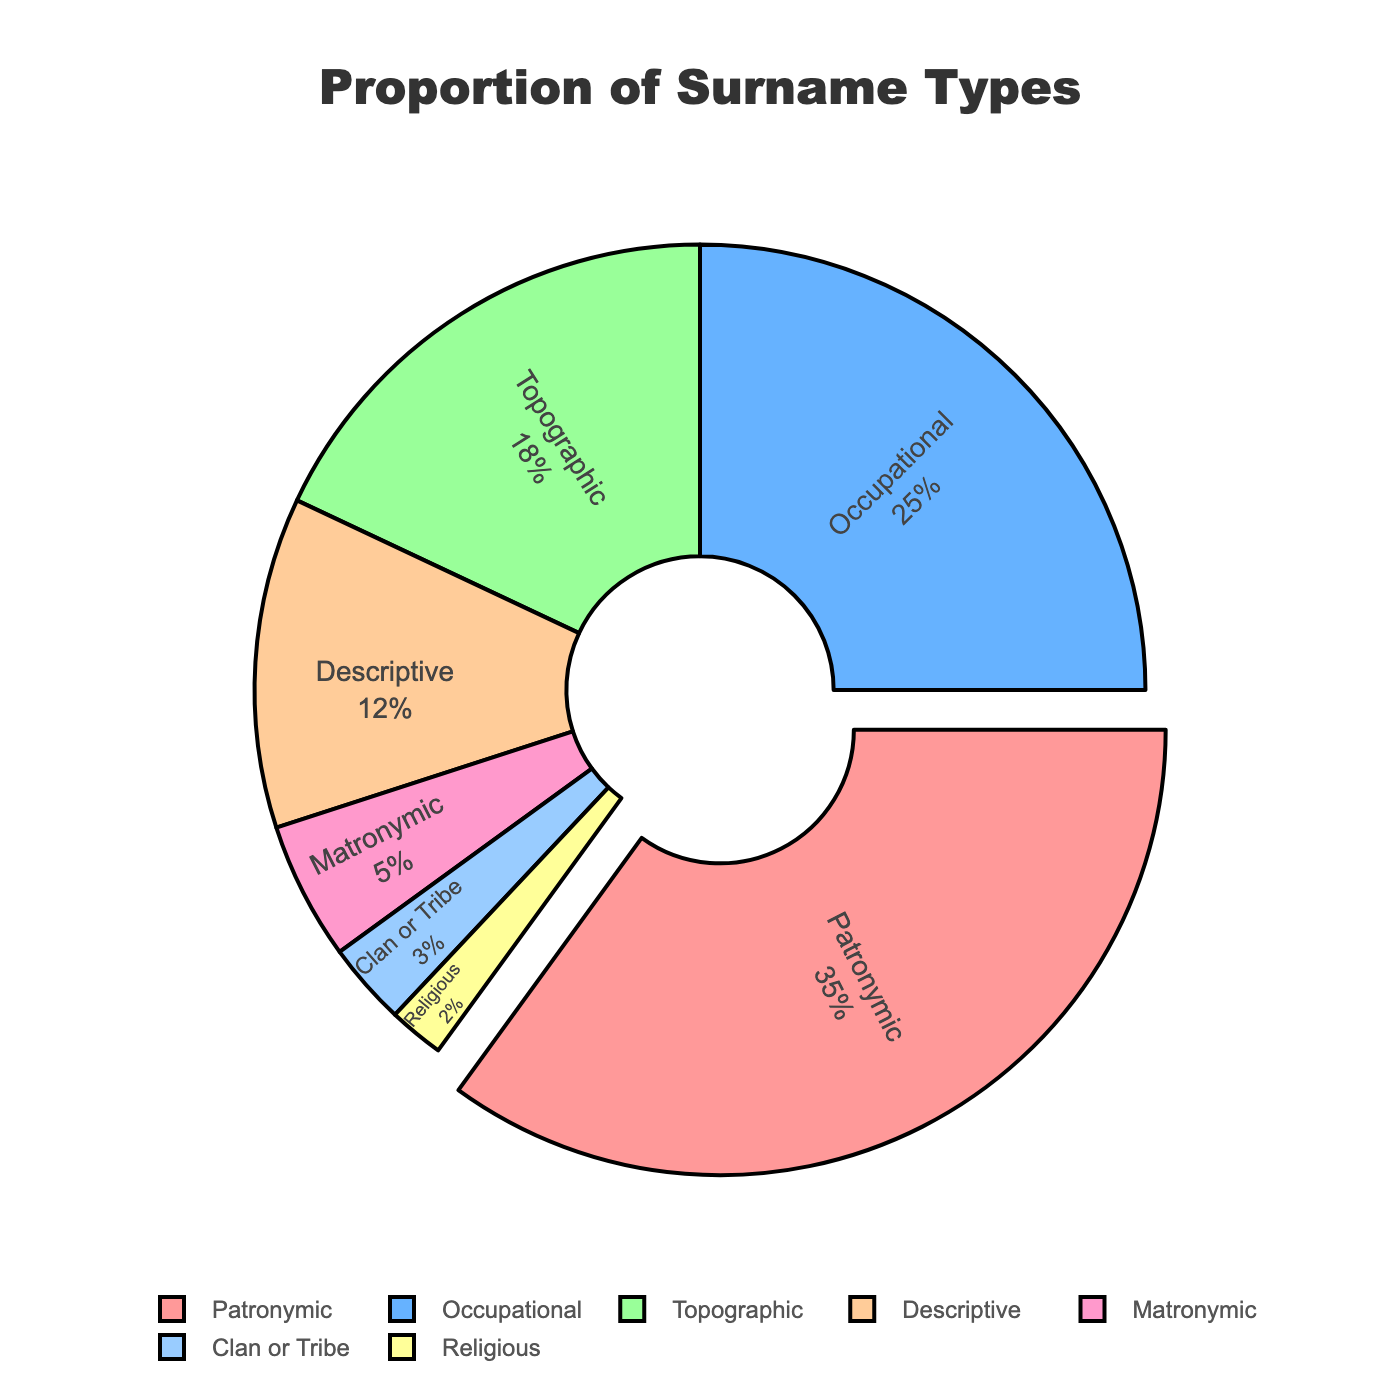What percentage of surnames are descriptive or religious? Add the percentages for 'Descriptive' and 'Religious'. Descriptive is 12% and Religious is 2%. 12% + 2% = 14%
Answer: 14% Which surname type is the most common? The largest slice of the pie chart represents the most common surname type. The 'Patronymic' slice is the largest at 35%.
Answer: Patronymic How many surname types make up more than 15%? Examine the pie chart and count the slices with percentages greater than 15%. 'Patronymic' (35%) and 'Occupational' (25%) are the only ones greater than 15%.
Answer: 2 Is the proportion of occupational surnames higher or lower than topographic surnames? Compare the percentages of 'Occupational' and 'Topographic' surnames. Occupational is 25% and Topographic is 18%. 25% is higher than 18%.
Answer: Higher If the pie chart were divided into two groups, one consisting of Patronymic and Occupational types and the other consisting of all other types, which group would be larger? Sum the percentages for 'Patronymic' and 'Occupational', and then for all other types: Patronymic + Occupational = 35% + 25% = 60%; All others = 100% - 60% = 40%. So, the first group (Patronymic and Occupational) is larger at 60%.
Answer: Patronymic and Occupational What is the combined percentage of the least common surname types? Add the percentages of the least common surname types 'Clan or Tribe' (3%) and 'Religious' (2%), which gives 3% + 2% = 5%.
Answer: 5% What color is used to represent the Matronymic surname type in the chart? Identify the slice with 'Matronymic' in the chart. The color used is light pink.
Answer: Light pink 